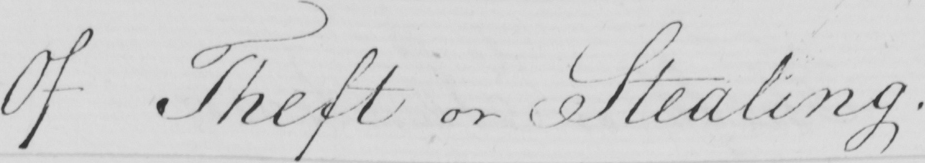What is written in this line of handwriting? Of Theft or Stealing . 